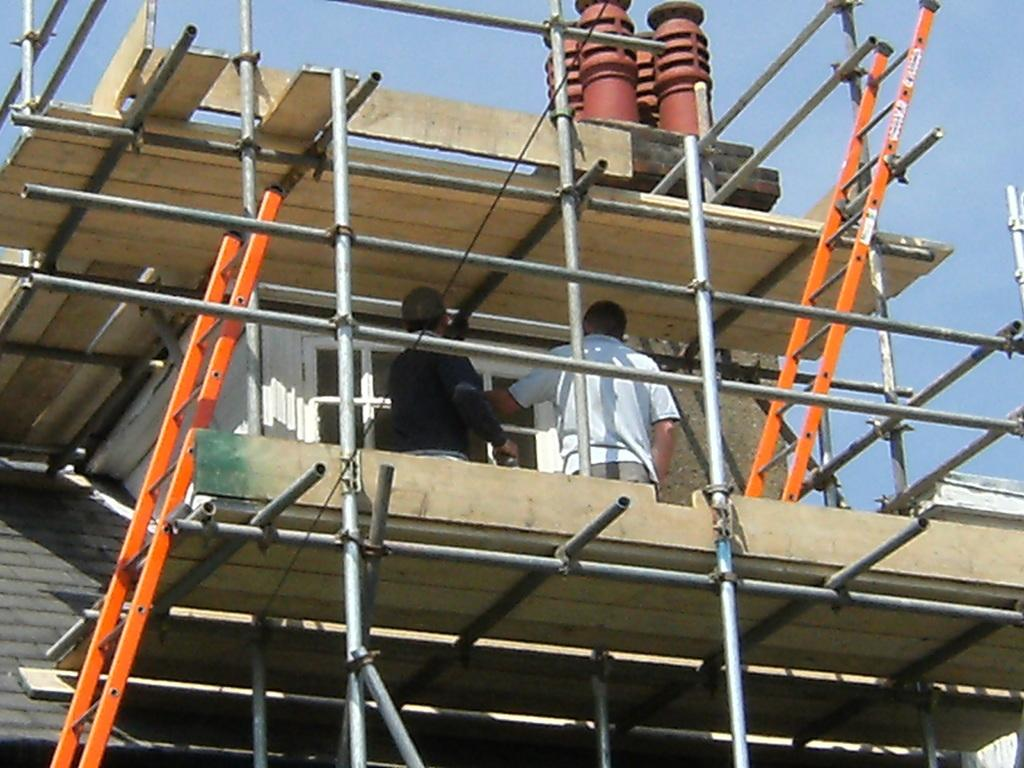What is the main subject of the image? The main subject of the image is a building under construction. What tools or equipment can be seen in the image? Ladders and iron rods are visible in the image. How many people are present in the image? There are two persons standing in the image. What can be seen in the background of the image? The sky is visible in the background of the image. What type of cushion is being used to support the engine in the image? There is no cushion or engine present in the image; it features a building under construction with ladders, iron rods, and two persons. 